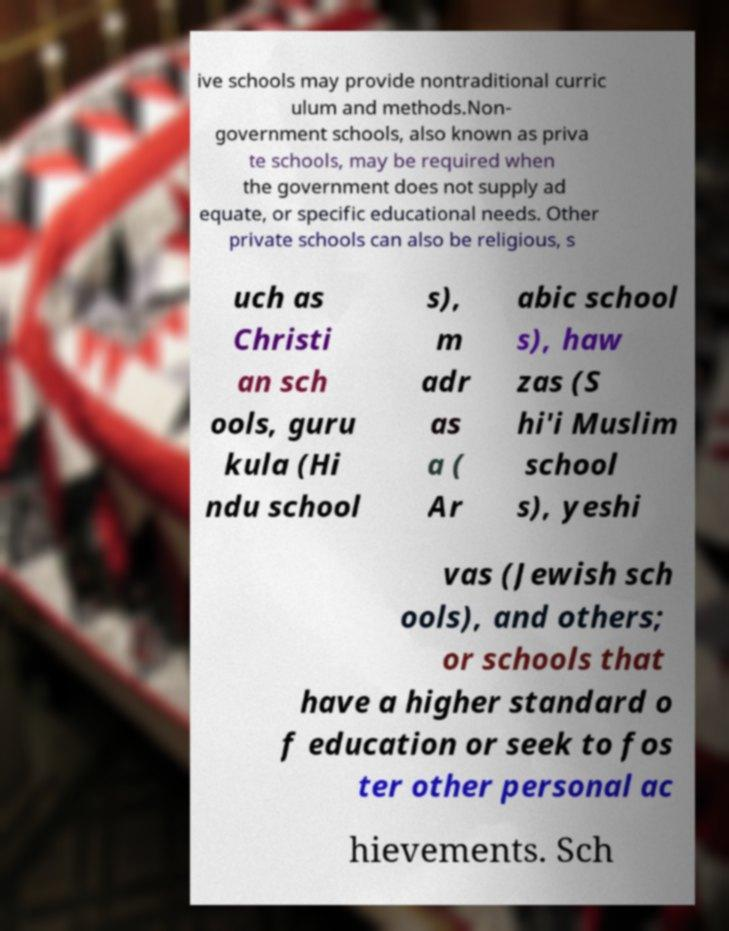Please read and relay the text visible in this image. What does it say? ive schools may provide nontraditional curric ulum and methods.Non- government schools, also known as priva te schools, may be required when the government does not supply ad equate, or specific educational needs. Other private schools can also be religious, s uch as Christi an sch ools, guru kula (Hi ndu school s), m adr as a ( Ar abic school s), haw zas (S hi'i Muslim school s), yeshi vas (Jewish sch ools), and others; or schools that have a higher standard o f education or seek to fos ter other personal ac hievements. Sch 